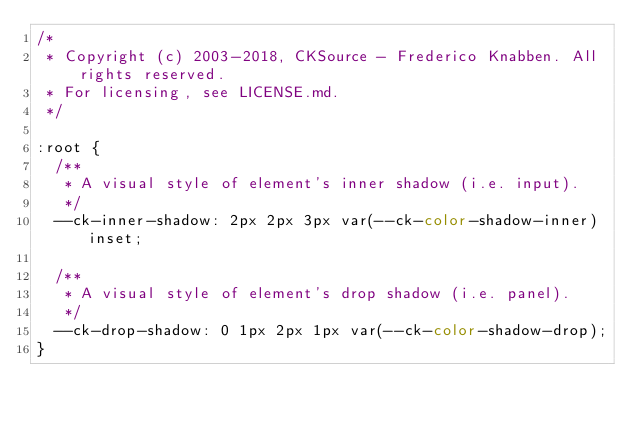<code> <loc_0><loc_0><loc_500><loc_500><_CSS_>/*
 * Copyright (c) 2003-2018, CKSource - Frederico Knabben. All rights reserved.
 * For licensing, see LICENSE.md.
 */

:root {
	/**
	 * A visual style of element's inner shadow (i.e. input).
	 */
	--ck-inner-shadow: 2px 2px 3px var(--ck-color-shadow-inner) inset;

	/**
	 * A visual style of element's drop shadow (i.e. panel).
	 */
	--ck-drop-shadow: 0 1px 2px 1px var(--ck-color-shadow-drop);
}
</code> 